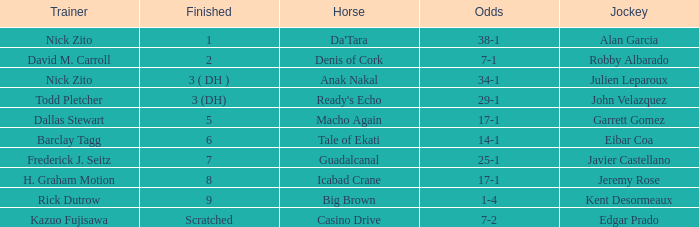What is the Finished place for da'tara trained by Nick zito? 1.0. 